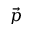<formula> <loc_0><loc_0><loc_500><loc_500>\vec { p }</formula> 